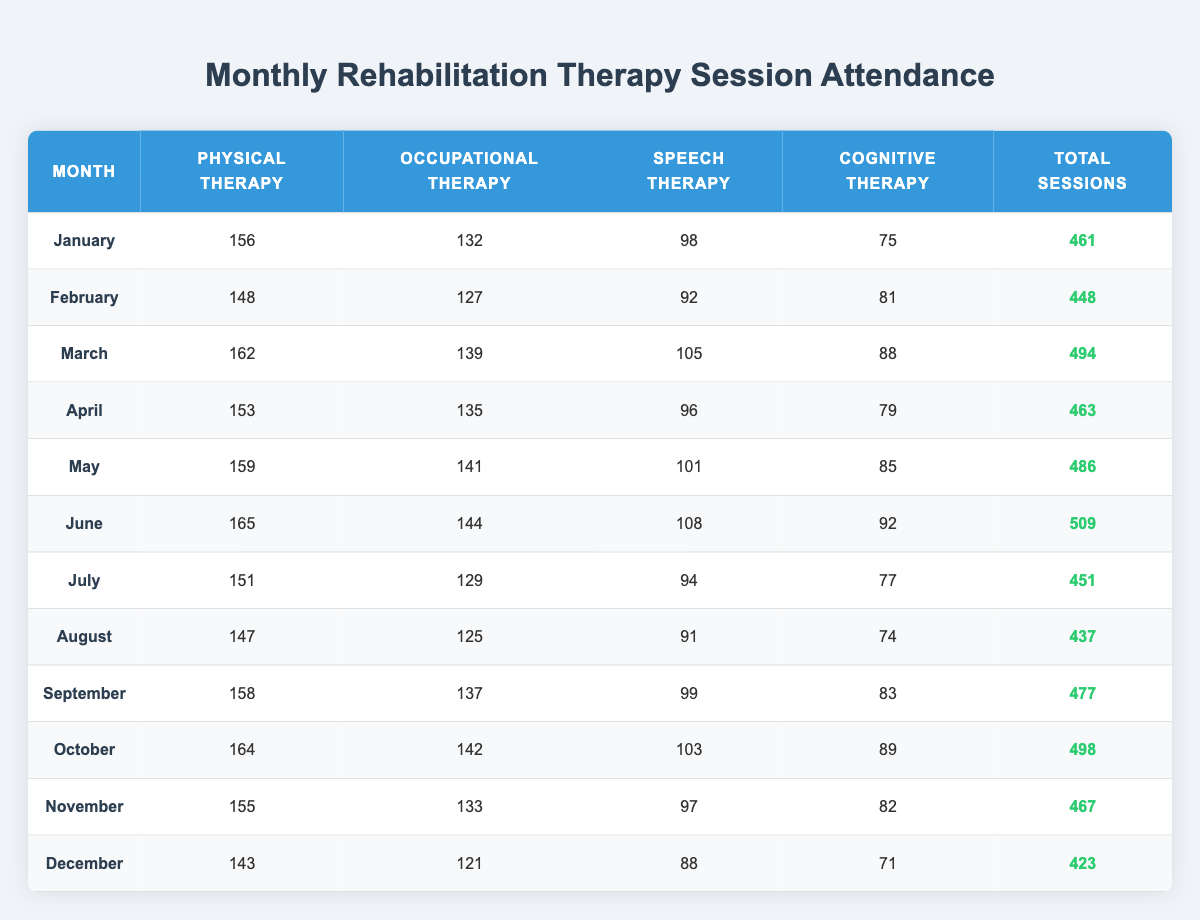What month had the highest attendance for Cognitive Therapy? Looking at the Cognitive Therapy column, the attendance values for each month are: January 75, February 81, March 88, April 79, May 85, June 92, July 77, August 74, September 83, October 89, November 82, December 71. The highest value is 92 in June.
Answer: June What is the total number of Speech Therapy sessions in October? Referring to the Speech Therapy column, the attendance for October is 103.
Answer: 103 Which therapy had the lowest total attendance throughout the year? To find the therapy with the lowest total attendance, we sum each therapy column: Physical Therapy = 1,725, Occupational Therapy = 1,602, Speech Therapy = 1,164, and Cognitive Therapy = 1,025. The lowest total is for Cognitive Therapy with 1,025 sessions.
Answer: Cognitive Therapy What is the average number of Physical Therapy sessions per month? There are 12 months with a total of 1,725 Physical Therapy sessions. To find the average, we divide 1,725 by 12, which results in approximately 143.75.
Answer: 143.75 Did the total number of sessions in December exceed 450? The total sessions in December are 423, which is less than 450.
Answer: No What was the increase in total sessions from January to June? The total sessions in January are 461 and in June are 509. The increase is calculated by subtracting January's total from June's: 509 - 461 = 48.
Answer: 48 Which month had the highest total number of therapy sessions? The total sessions for each month are: January 461, February 448, March 494, April 463, May 486, June 509, July 451, August 437, September 477, October 498, November 467, December 423. June has the highest total with 509 sessions.
Answer: June What was the total attendance for Occupational Therapy from July to December? The Occupational Therapy attendance from July to December is: July 129, August 125, September 137, October 142, November 133, December 121. Summing these gives 129 + 125 + 137 + 142 + 133 + 121 = 787.
Answer: 787 In which month did the total number of therapy sessions first fall below 450? The total sessions for each month are as follows: January 461, February 448, March 494, April 463, May 486, June 509, July 451, August 437, September 477, October 498, November 467, December 423. August is the first month below 450 with 437 sessions.
Answer: August 